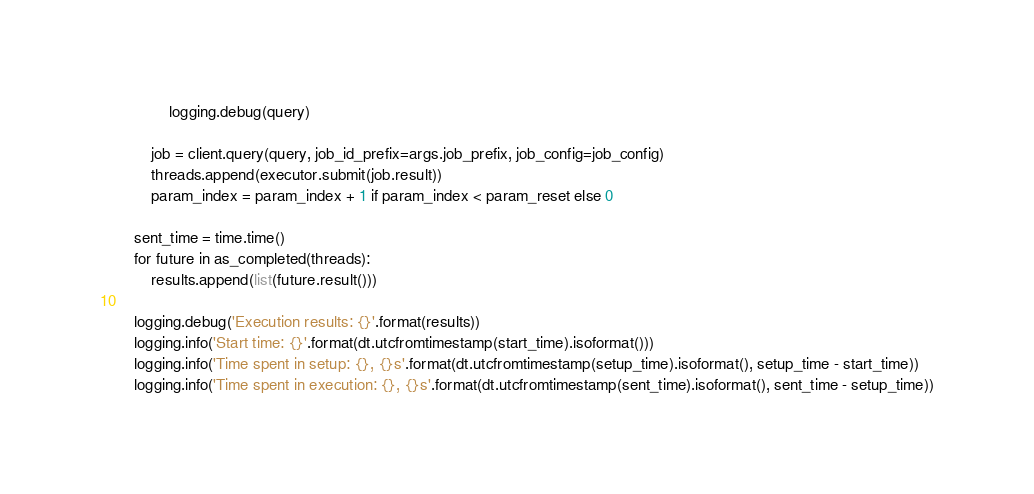Convert code to text. <code><loc_0><loc_0><loc_500><loc_500><_Python_>            logging.debug(query)

        job = client.query(query, job_id_prefix=args.job_prefix, job_config=job_config)
        threads.append(executor.submit(job.result))
        param_index = param_index + 1 if param_index < param_reset else 0

    sent_time = time.time()
    for future in as_completed(threads):
        results.append(list(future.result()))
        
    logging.debug('Execution results: {}'.format(results))
    logging.info('Start time: {}'.format(dt.utcfromtimestamp(start_time).isoformat()))
    logging.info('Time spent in setup: {}, {}s'.format(dt.utcfromtimestamp(setup_time).isoformat(), setup_time - start_time))
    logging.info('Time spent in execution: {}, {}s'.format(dt.utcfromtimestamp(sent_time).isoformat(), sent_time - setup_time))</code> 